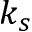Convert formula to latex. <formula><loc_0><loc_0><loc_500><loc_500>k _ { s }</formula> 